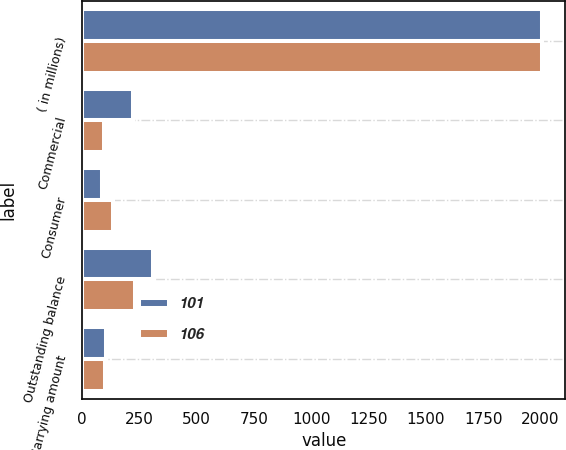Convert chart to OTSL. <chart><loc_0><loc_0><loc_500><loc_500><stacked_bar_chart><ecel><fcel>( in millions)<fcel>Commercial<fcel>Consumer<fcel>Outstanding balance<fcel>Carrying amount<nl><fcel>101<fcel>2008<fcel>224<fcel>87<fcel>311<fcel>106<nl><fcel>106<fcel>2007<fcel>94<fcel>135<fcel>229<fcel>101<nl></chart> 